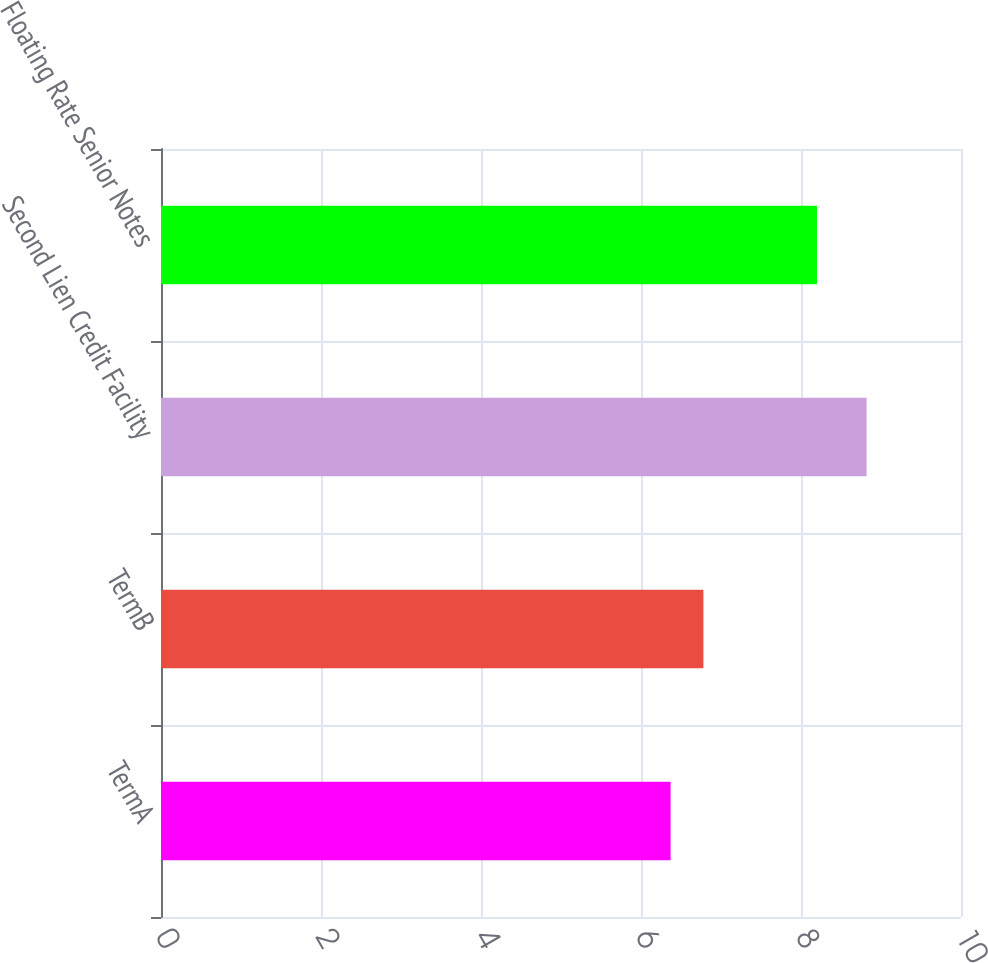Convert chart to OTSL. <chart><loc_0><loc_0><loc_500><loc_500><bar_chart><fcel>TermA<fcel>TermB<fcel>Second Lien Credit Facility<fcel>Floating Rate Senior Notes<nl><fcel>6.37<fcel>6.78<fcel>8.82<fcel>8.2<nl></chart> 